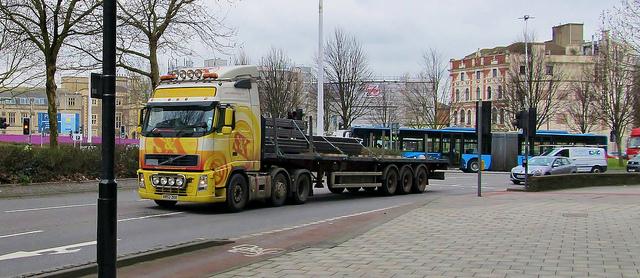How many trees are in the far left?
Write a very short answer. 2. What is this truck carrying?
Answer briefly. Wood. What color is the bus in this image?
Answer briefly. Blue. What is the truck carrying?
Be succinct. Wood. 